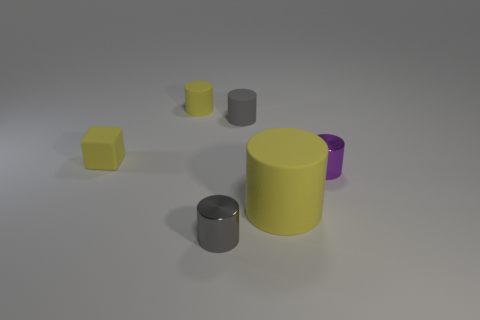Add 1 metal cylinders. How many objects exist? 7 Add 6 yellow rubber cubes. How many yellow rubber cubes are left? 7 Add 5 large cylinders. How many large cylinders exist? 6 Subtract all yellow cylinders. How many cylinders are left? 3 Subtract all tiny metal cylinders. How many cylinders are left? 3 Subtract 0 cyan spheres. How many objects are left? 6 Subtract all cylinders. How many objects are left? 1 Subtract 1 cylinders. How many cylinders are left? 4 Subtract all purple cylinders. Subtract all green spheres. How many cylinders are left? 4 Subtract all green balls. How many gray cylinders are left? 2 